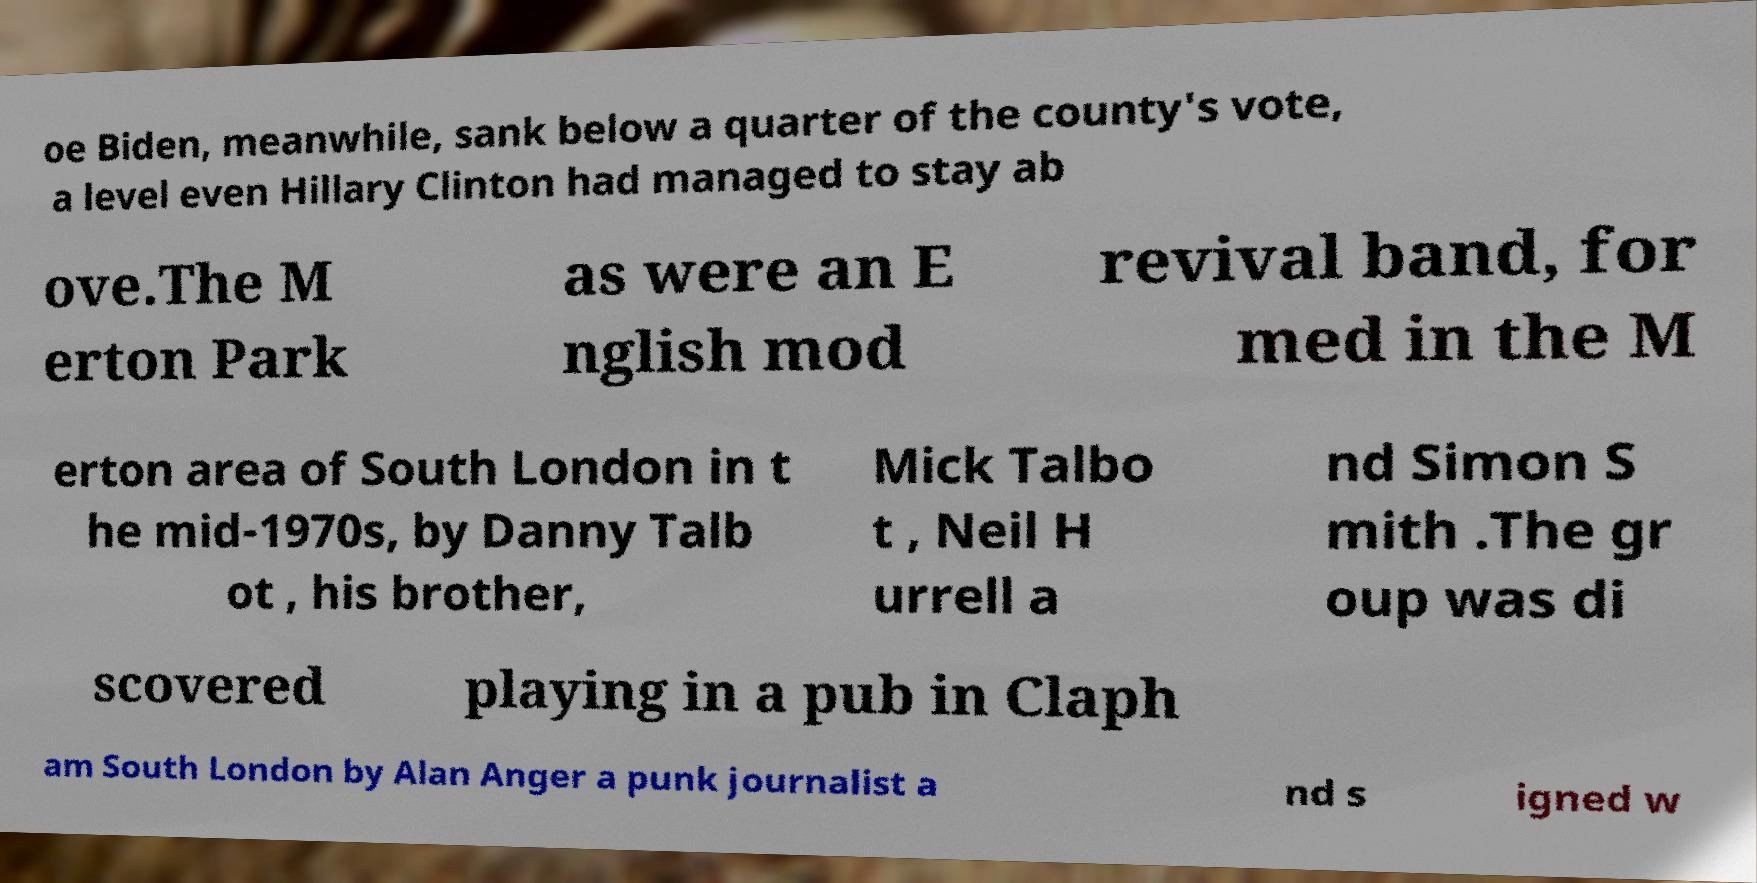What messages or text are displayed in this image? I need them in a readable, typed format. oe Biden, meanwhile, sank below a quarter of the county's vote, a level even Hillary Clinton had managed to stay ab ove.The M erton Park as were an E nglish mod revival band, for med in the M erton area of South London in t he mid-1970s, by Danny Talb ot , his brother, Mick Talbo t , Neil H urrell a nd Simon S mith .The gr oup was di scovered playing in a pub in Claph am South London by Alan Anger a punk journalist a nd s igned w 